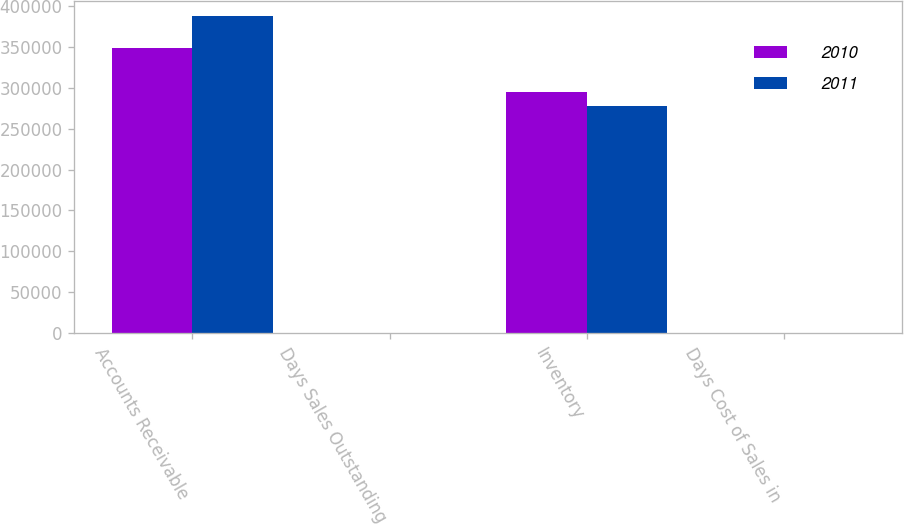Convert chart. <chart><loc_0><loc_0><loc_500><loc_500><stacked_bar_chart><ecel><fcel>Accounts Receivable<fcel>Days Sales Outstanding<fcel>Inventory<fcel>Days Cost of Sales in<nl><fcel>2010<fcel>348416<fcel>44<fcel>295081<fcel>105<nl><fcel>2011<fcel>387169<fcel>46<fcel>277478<fcel>100<nl></chart> 